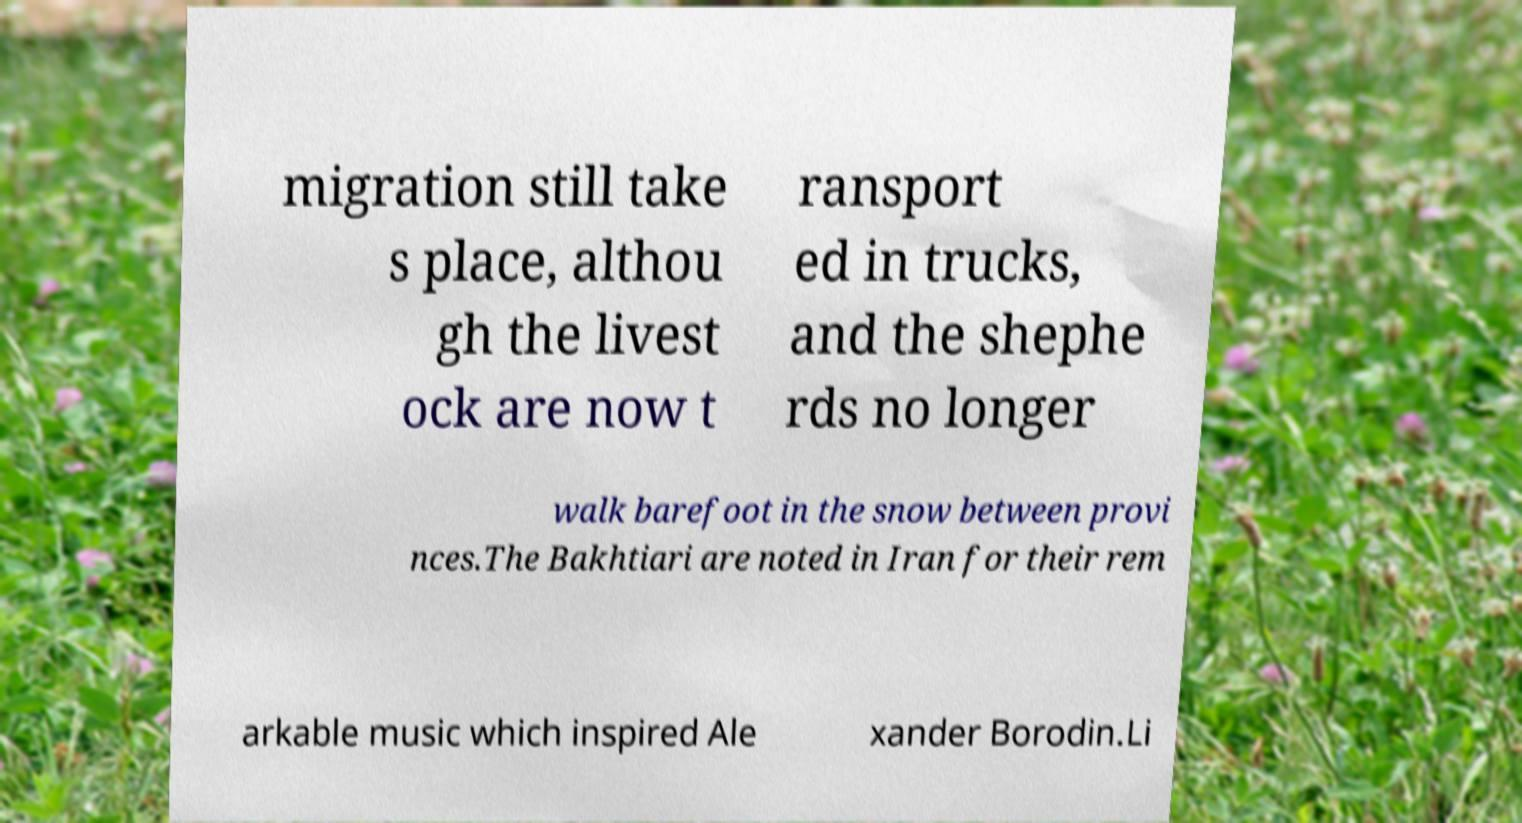Please read and relay the text visible in this image. What does it say? migration still take s place, althou gh the livest ock are now t ransport ed in trucks, and the shephe rds no longer walk barefoot in the snow between provi nces.The Bakhtiari are noted in Iran for their rem arkable music which inspired Ale xander Borodin.Li 